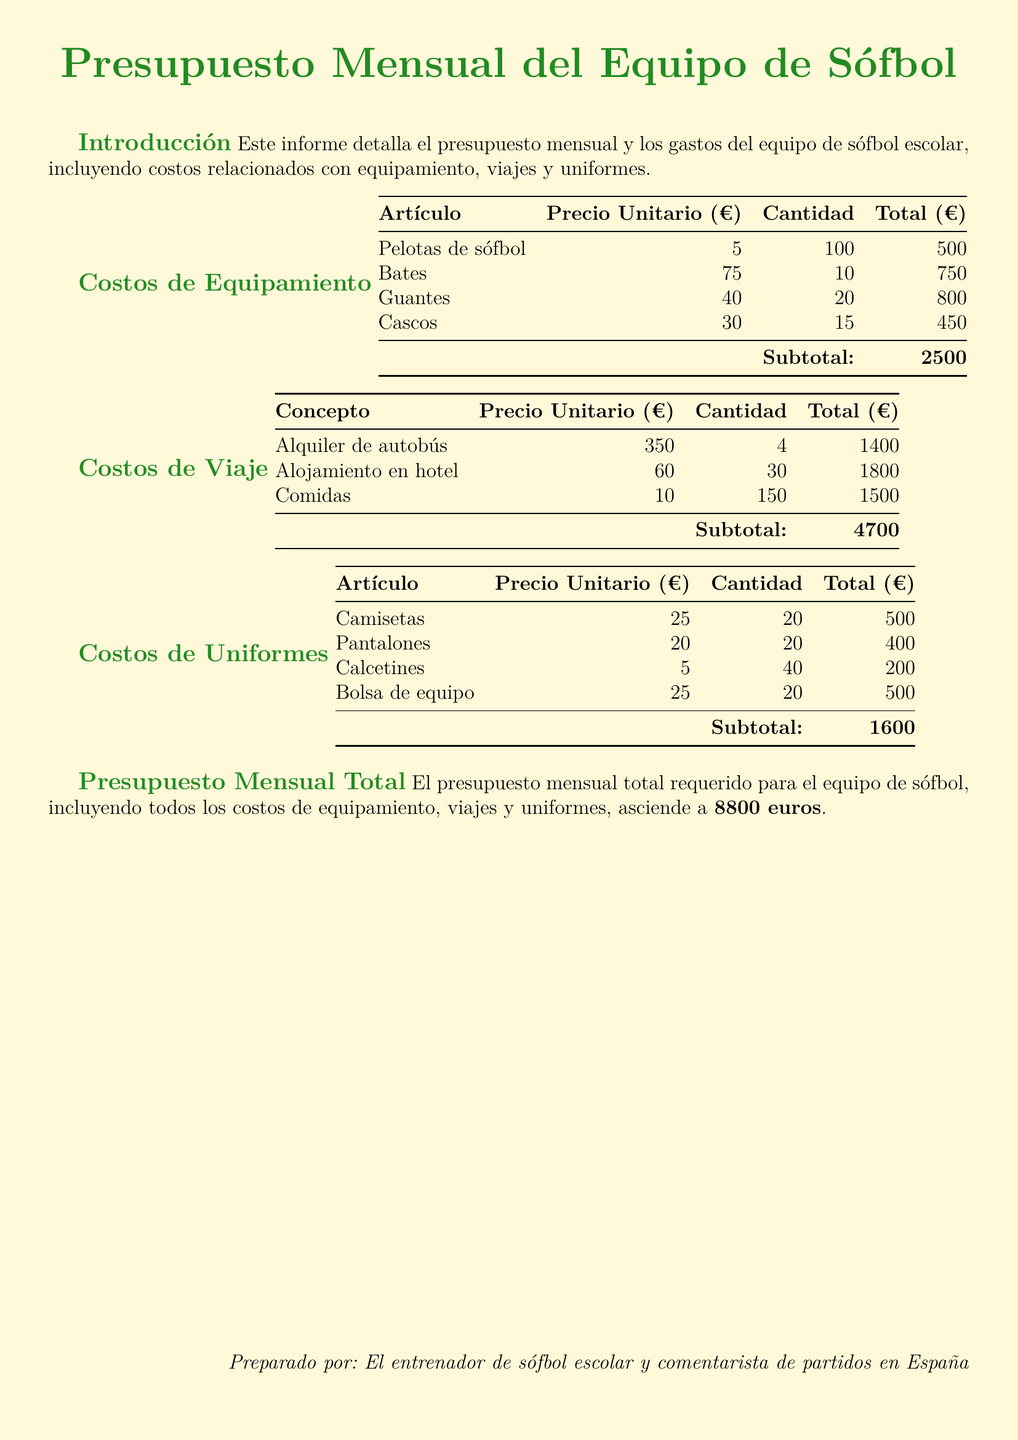¿Cuál es el costo total de equipamiento? El costo total de equipamiento se encuentra en la sección de costos de equipamiento, sumando todos los artículos.
Answer: 2500 euros ¿Cuál es el costo por alojamiento en hotel? El costo por alojamiento en hotel se indica en la tabla de costos de viaje.
Answer: 60 euros ¿Cuántas camisetas se han solicitado? La cantidad de camisetas se encuentra en la tabla de costos de uniformes.
Answer: 20 ¿Cuál es el costo total de los viajes? El costo total de los viajes se puede deducir de la sección de costos de viaje sumando los subtotales.
Answer: 4700 euros ¿Cuánto se gastará en uniformes en total? El total de gastos en uniformes está especificado en la tabla de uniformes de la sección correspondiente.
Answer: 1600 euros ¿Cuál es el presupuesto mensual total para el equipo? El presupuesto mensual total se menciona claramente al final del documento.
Answer: 8800 euros ¿Cuál es el precio unitario de los bates? El precio unitario de los bates se menciona en la tabla de costos de equipamiento.
Answer: 75 euros ¿Cuántas comidas están presupuestadas? La cantidad de comidas está indicada en la sección de costos de viaje.
Answer: 150 ¿Cuántos guantes se han comprado? La cantidad de guantes puede encontrarse en la sección de costos de equipamiento.
Answer: 20 